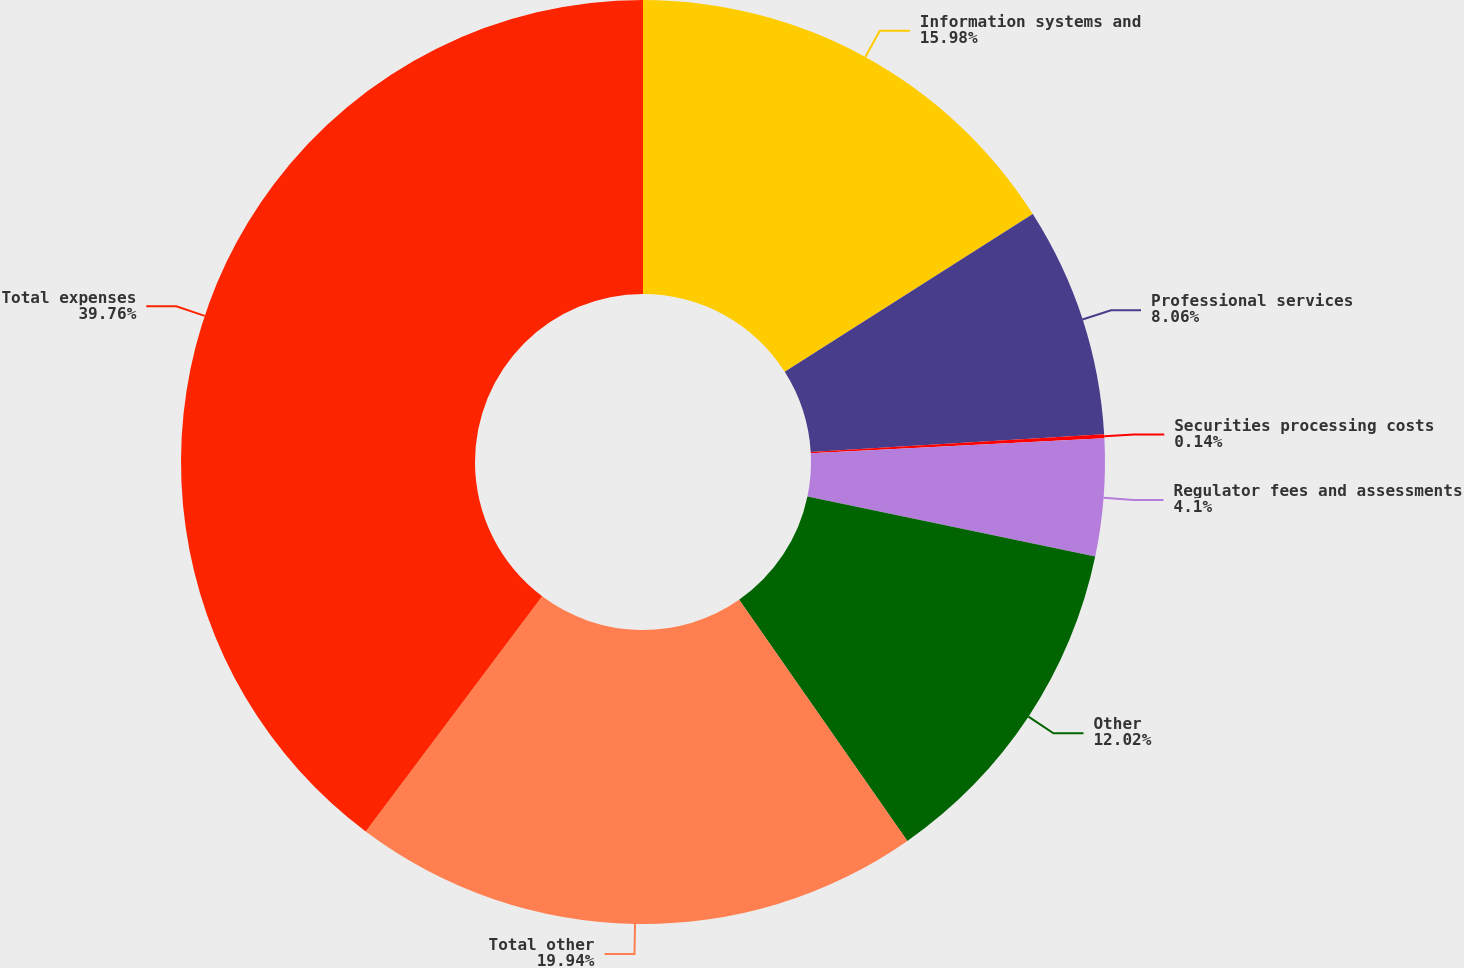Convert chart to OTSL. <chart><loc_0><loc_0><loc_500><loc_500><pie_chart><fcel>Information systems and<fcel>Professional services<fcel>Securities processing costs<fcel>Regulator fees and assessments<fcel>Other<fcel>Total other<fcel>Total expenses<nl><fcel>15.98%<fcel>8.06%<fcel>0.14%<fcel>4.1%<fcel>12.02%<fcel>19.94%<fcel>39.75%<nl></chart> 